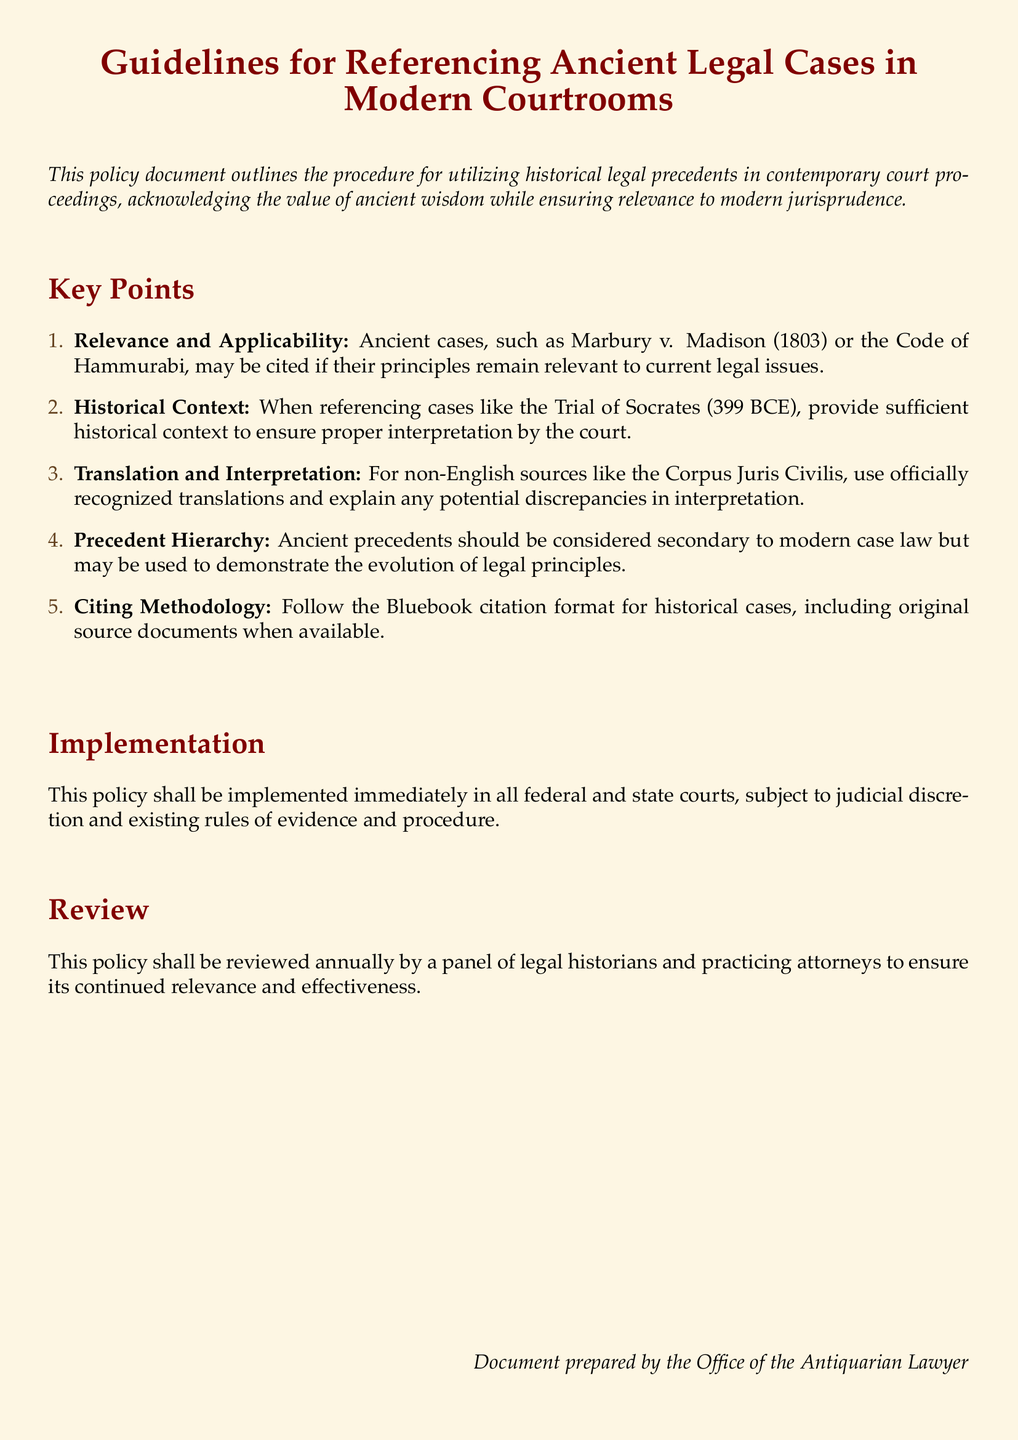What is the title of the document? The title is the main heading presented at the top of the document, which summarizes its purpose.
Answer: Guidelines for Referencing Ancient Legal Cases in Modern Courtrooms What case is mentioned as an example of an ancient precedent? The document lists this case to illustrate sources that may be cited for their relevance.
Answer: Marbury v. Madison What year did the Trial of Socrates take place? The document states the year of this historical trial as a reference point in legal history.
Answer: 399 BCE What is the citation format to be followed for historical cases? The document specifies the required citation method for referencing these cases accurately.
Answer: Bluebook citation format Are ancient precedents considered primary or secondary? This information highlights the document's stance on the hierarchy of legal references.
Answer: Secondary Who will review the policy annually? This specifies the responsible parties for the periodic evaluation of the policy's relevance and effectiveness.
Answer: Legal historians and practicing attorneys What is required when referencing non-English sources? The document emphasizes the necessity of using recognized translations for clarity.
Answer: Translate and explain When will this policy be implemented? The implementation date is crucial for understanding its immediate applicability in legal contexts.
Answer: Immediately 